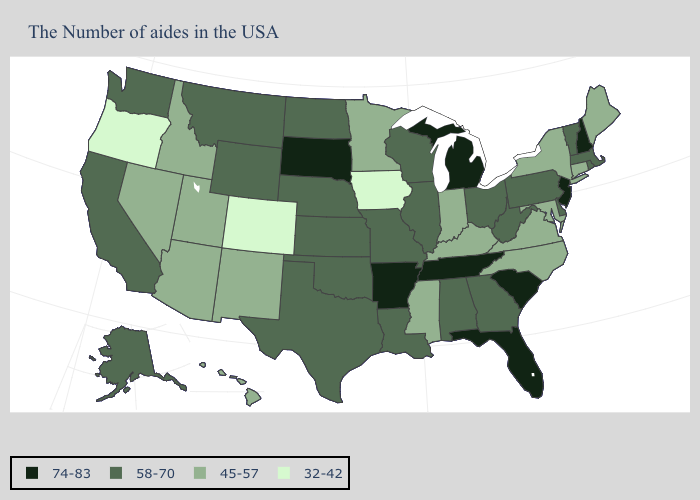Among the states that border New Jersey , which have the lowest value?
Quick response, please. New York. Name the states that have a value in the range 74-83?
Concise answer only. New Hampshire, New Jersey, South Carolina, Florida, Michigan, Tennessee, Arkansas, South Dakota. What is the highest value in the USA?
Give a very brief answer. 74-83. Does North Dakota have a higher value than North Carolina?
Concise answer only. Yes. Does New Hampshire have the highest value in the Northeast?
Be succinct. Yes. What is the value of Oregon?
Answer briefly. 32-42. What is the value of Nevada?
Be succinct. 45-57. Which states have the lowest value in the Northeast?
Concise answer only. Maine, Connecticut, New York. Does Rhode Island have a lower value than Tennessee?
Be succinct. Yes. What is the value of North Dakota?
Concise answer only. 58-70. Does California have a higher value than Mississippi?
Concise answer only. Yes. Name the states that have a value in the range 58-70?
Write a very short answer. Massachusetts, Rhode Island, Vermont, Delaware, Pennsylvania, West Virginia, Ohio, Georgia, Alabama, Wisconsin, Illinois, Louisiana, Missouri, Kansas, Nebraska, Oklahoma, Texas, North Dakota, Wyoming, Montana, California, Washington, Alaska. What is the value of New Jersey?
Write a very short answer. 74-83. Does Illinois have the lowest value in the MidWest?
Be succinct. No. What is the lowest value in the USA?
Give a very brief answer. 32-42. 